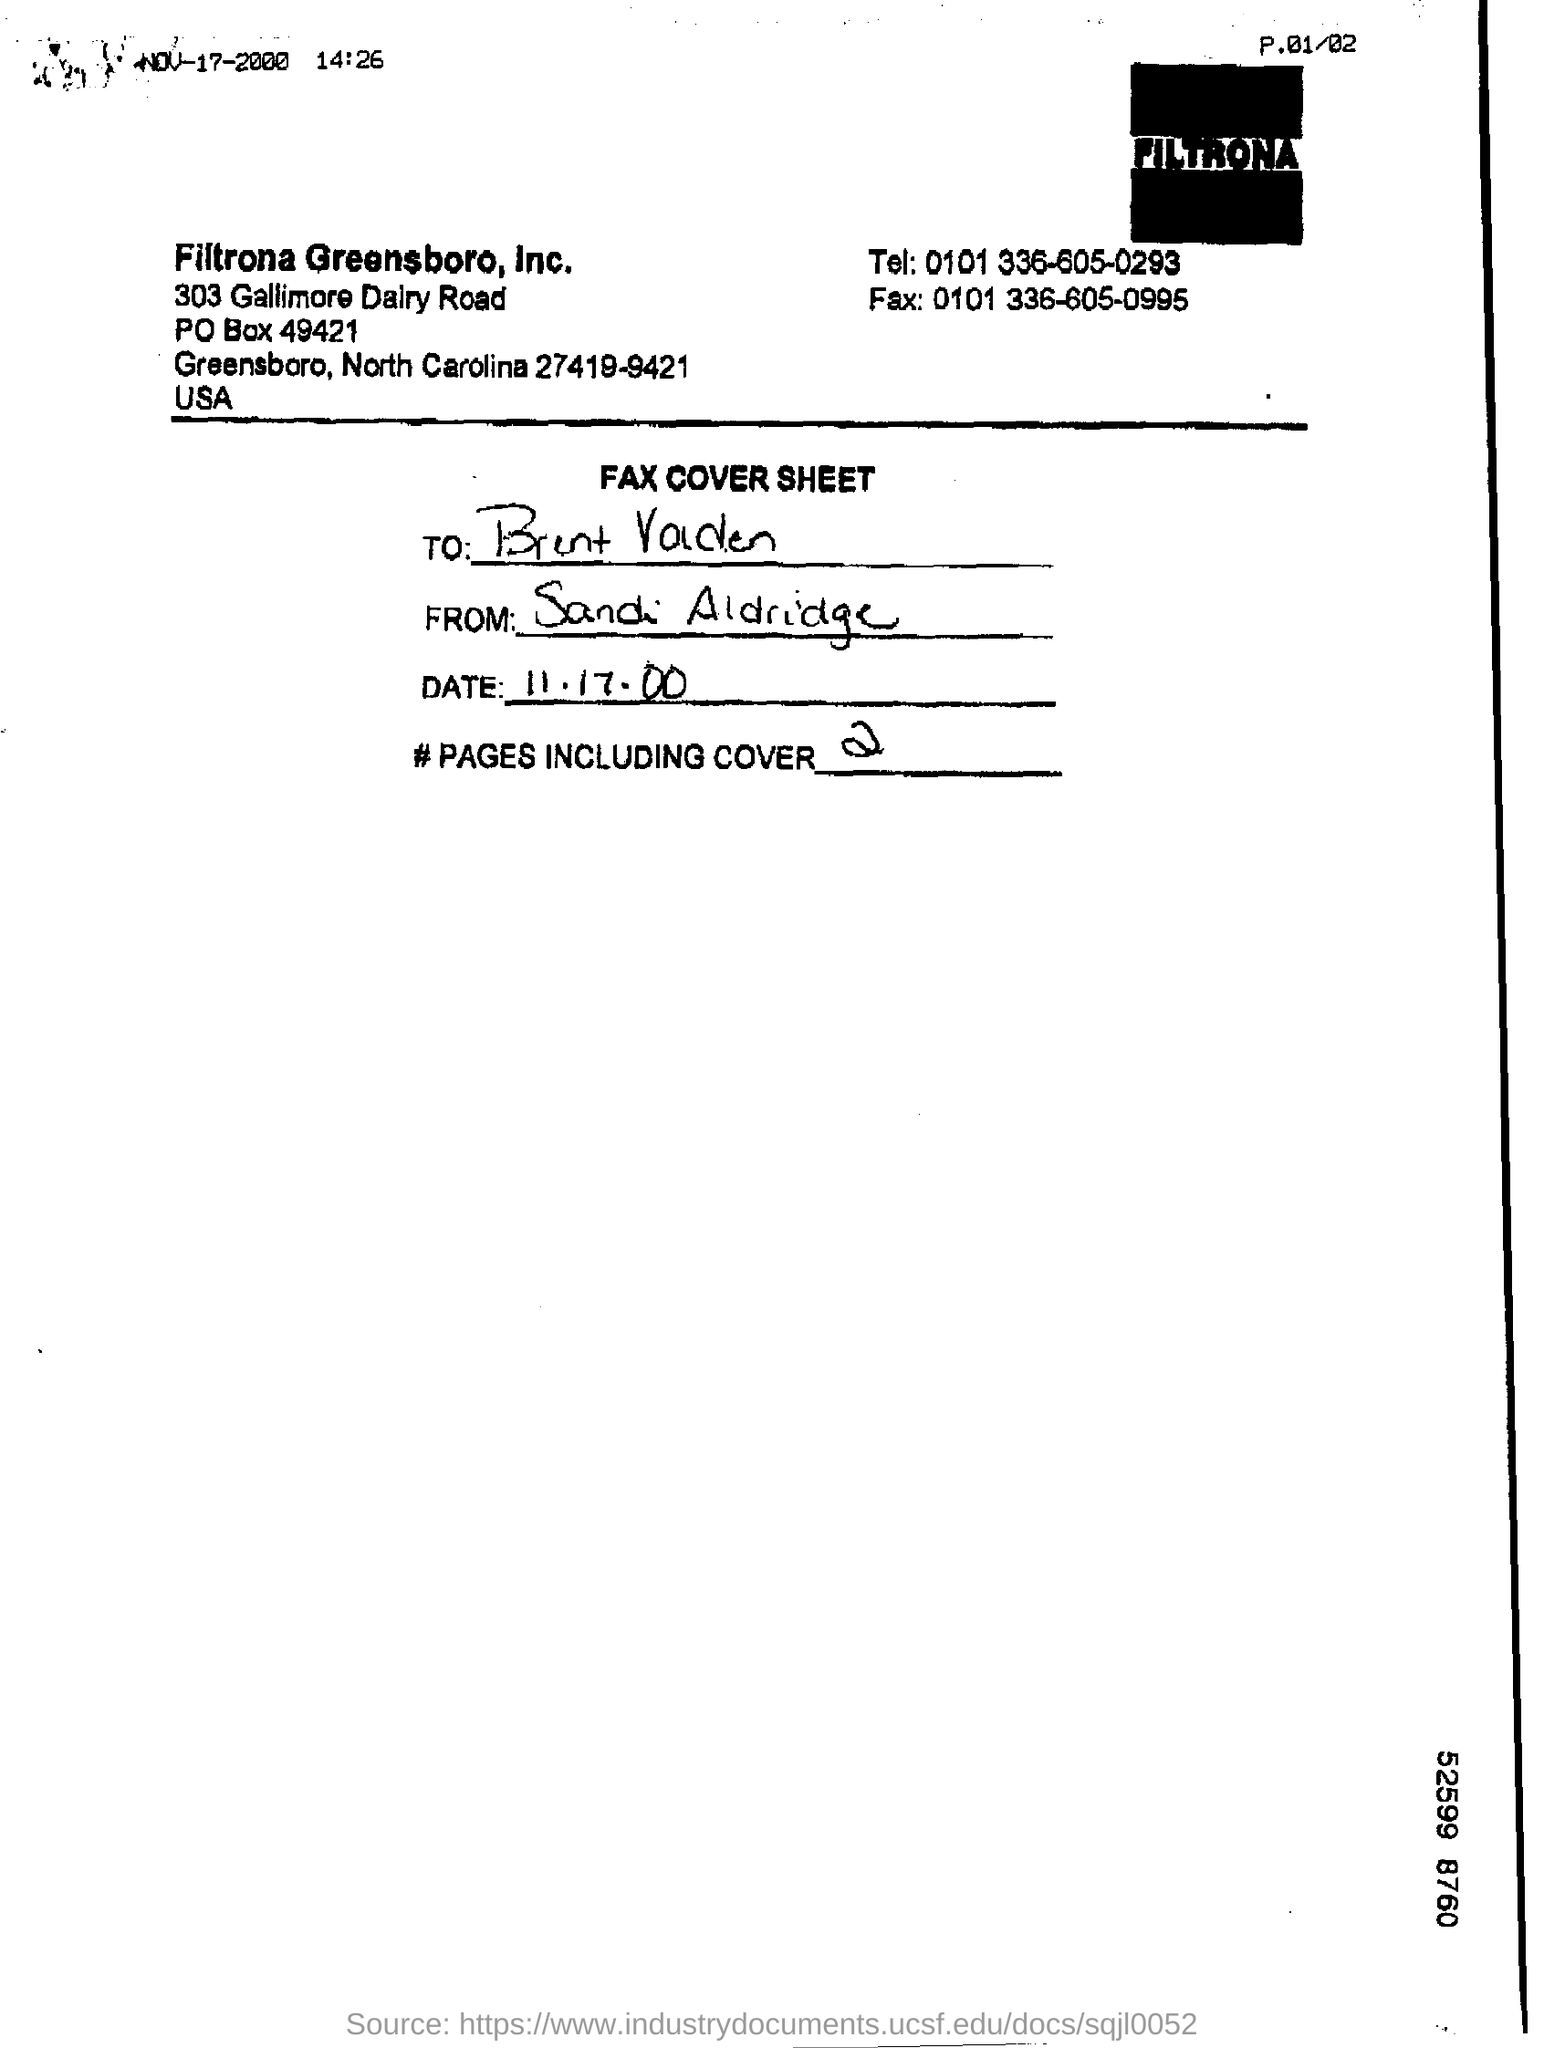Which company's fax cover sheet is this?
Provide a short and direct response. Filtrona. How many pages are there in the fax including cover?
Keep it short and to the point. 2. What is the Fax number given ?
Your response must be concise. 0101 336-605-0995. 